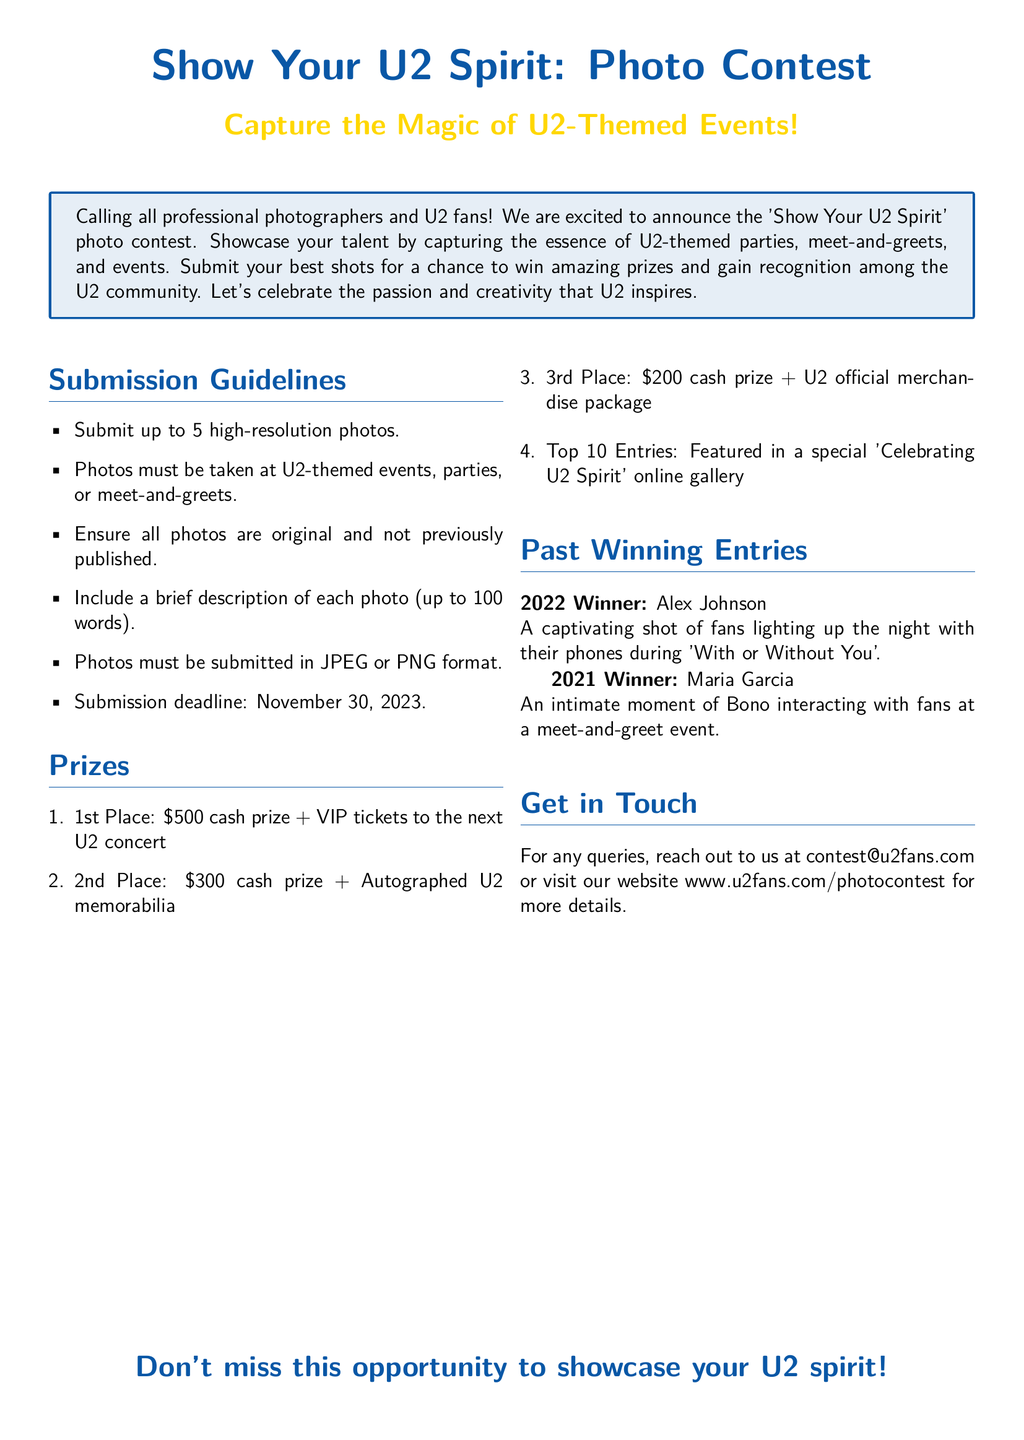What is the submission deadline? The document specifies the deadline for photo submissions, which is stated clearly in the guidelines section.
Answer: November 30, 2023 What is the cash prize for 1st Place? The prize section lists the 1st Place award specifically, including the cash amount.
Answer: $500 How many photos can be submitted? The guidelines indicate a specific limit on the number of photos that participants can send in for the contest.
Answer: 5 Who is the 2022 winner? The document provides information about past winners, including names and notable entries for the specified years.
Answer: Alex Johnson What format must the photos be submitted in? The guidelines detail the accepted formats for photo submissions.
Answer: JPEG or PNG What type of event should the photos depict? The submission guidelines clearly outline the context in which the photos must be taken.
Answer: U2-themed events What prize do the top 10 entries receive? The prizes section includes rewards for various placements, including a specific mention of the top entries resulting in recognition.
Answer: Featured in a special 'Celebrating U2 Spirit' online gallery Which U2 song was highlighted by the 2022 winner? The description of the 2022 winning entry includes a specific U2 song, indicating its significance to the photo.
Answer: With or Without You What is the email address for queries? The contact section provides the email address for any questions related to the contest.
Answer: contest@u2fans.com 